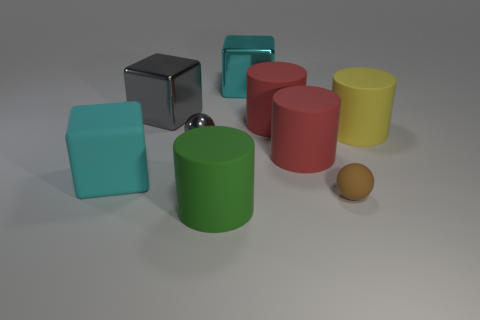There is a ball that is right of the green cylinder; how big is it?
Make the answer very short. Small. What number of objects are the same size as the green rubber cylinder?
Make the answer very short. 6. Does the gray metal cube have the same size as the gray shiny object that is in front of the large yellow matte cylinder?
Your answer should be compact. No. How many things are small brown things or gray metallic blocks?
Keep it short and to the point. 2. How many metallic blocks have the same color as the tiny metallic sphere?
Offer a very short reply. 1. There is a gray metallic object that is the same size as the brown rubber object; what is its shape?
Your response must be concise. Sphere. Is there another cyan rubber thing that has the same shape as the cyan rubber thing?
Offer a terse response. No. What number of gray spheres have the same material as the big green object?
Offer a very short reply. 0. Does the small thing that is behind the tiny rubber thing have the same material as the large yellow cylinder?
Your answer should be compact. No. Is the number of green cylinders in front of the large yellow thing greater than the number of tiny metal balls that are behind the gray shiny sphere?
Your answer should be compact. Yes. 